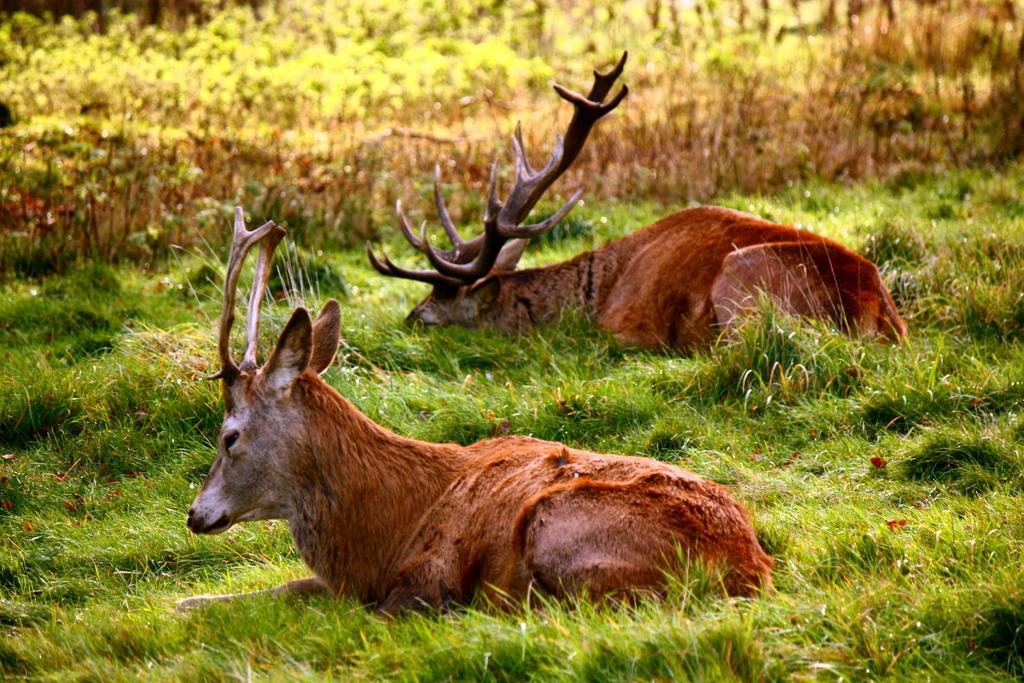How many animals are present in the image? There are two animals in the image. What are the animals doing in the image? The animals are sitting on the grass. Where is the grass located in the image? The grass is on the ground. What can be seen in the background of the image? There are plants visible in the background of the image. What type of pet is the goat in the image? There is no goat present in the image; the animals in the image are not specified as pets. 